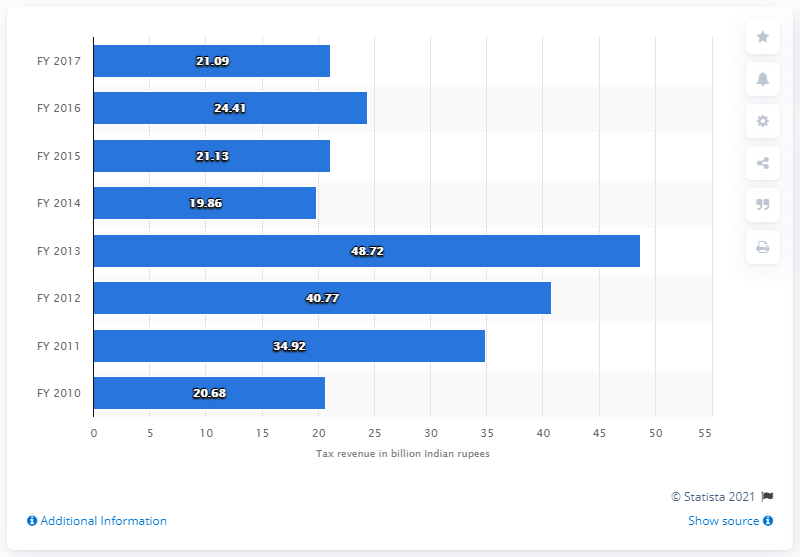List a handful of essential elements in this visual. In fiscal year 2017, a total of Rs. 21.09 crore was generated through the levy of duty on tires and tubes. 